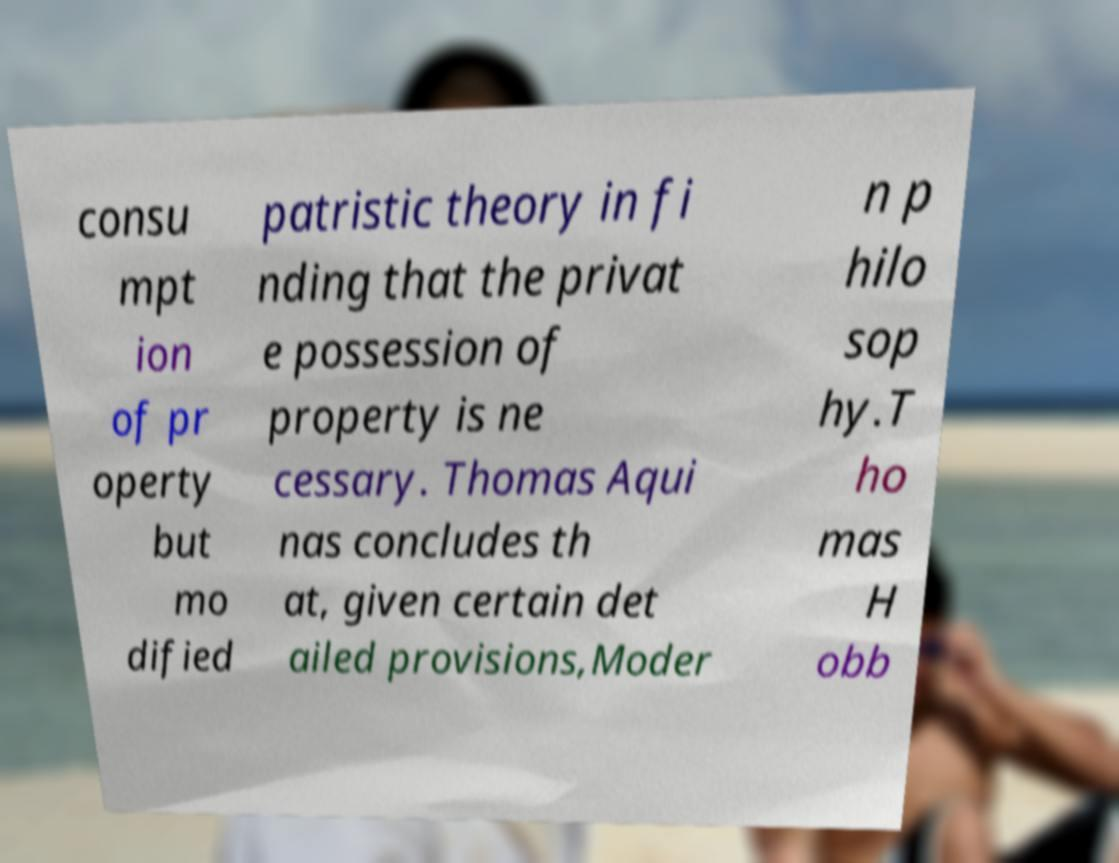What messages or text are displayed in this image? I need them in a readable, typed format. consu mpt ion of pr operty but mo dified patristic theory in fi nding that the privat e possession of property is ne cessary. Thomas Aqui nas concludes th at, given certain det ailed provisions,Moder n p hilo sop hy.T ho mas H obb 